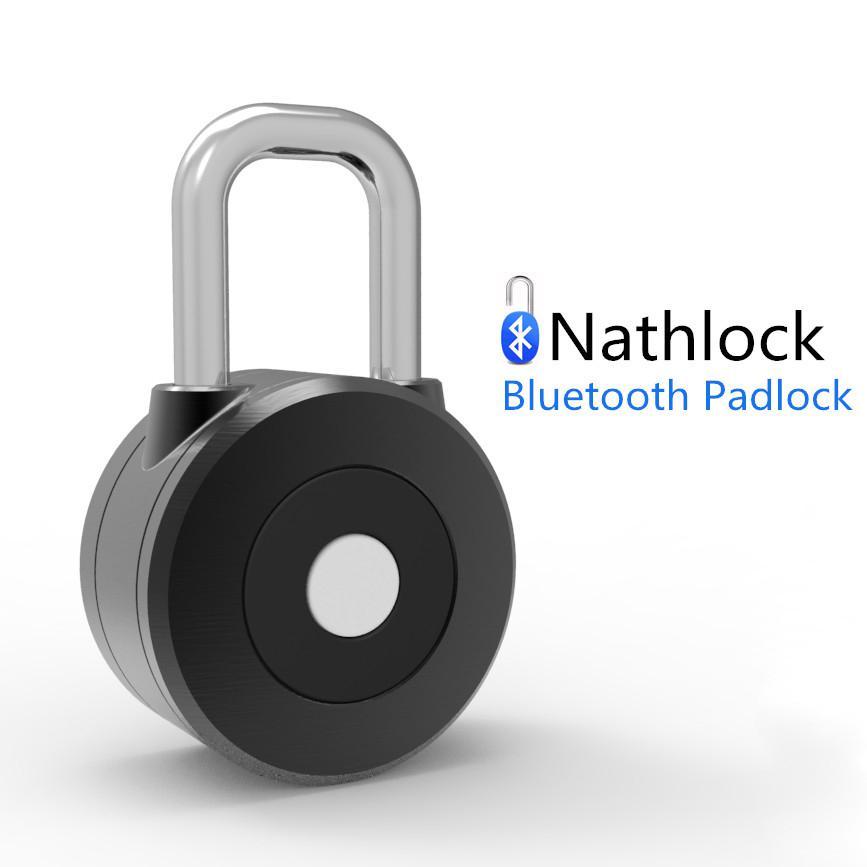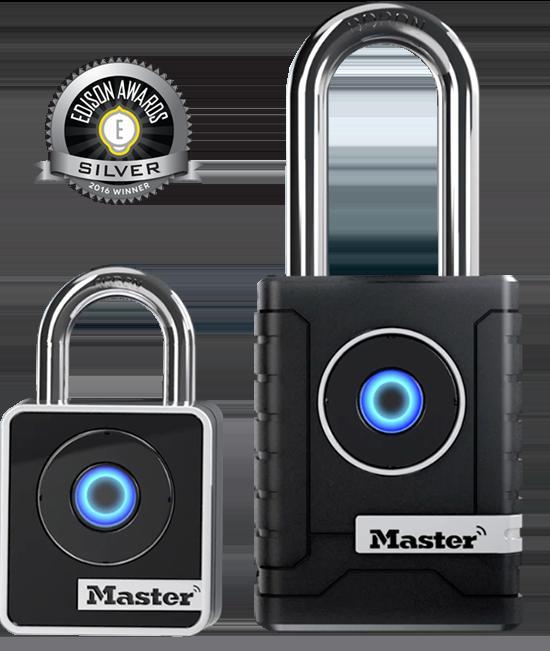The first image is the image on the left, the second image is the image on the right. Evaluate the accuracy of this statement regarding the images: "There are two locks.". Is it true? Answer yes or no. No. The first image is the image on the left, the second image is the image on the right. Evaluate the accuracy of this statement regarding the images: "There are at least three padlocks.". Is it true? Answer yes or no. Yes. 